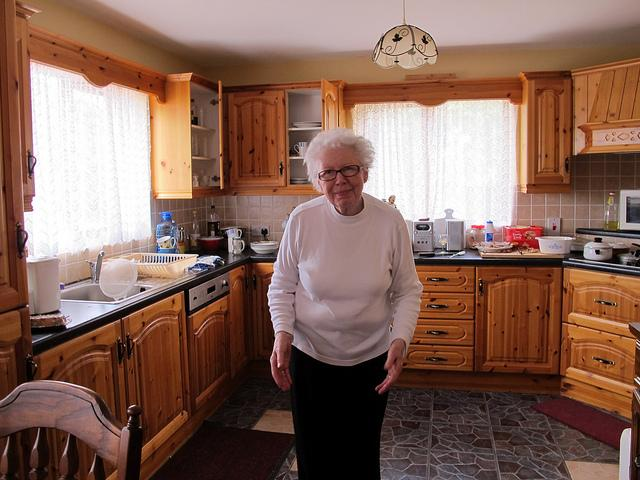Which term would best describe this woman? Please explain your reasoning. octogenarian. The woman in the kitchen looks to be in her eighties which would make her an octogenarian. 